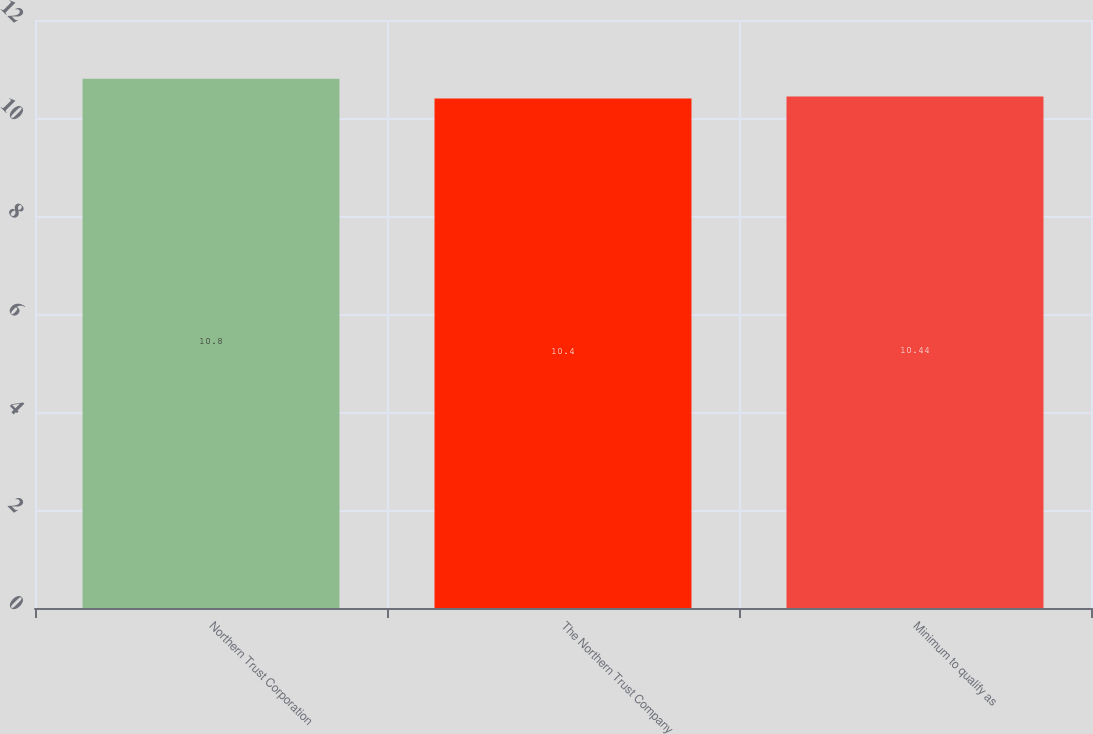<chart> <loc_0><loc_0><loc_500><loc_500><bar_chart><fcel>Northern Trust Corporation<fcel>The Northern Trust Company<fcel>Minimum to qualify as<nl><fcel>10.8<fcel>10.4<fcel>10.44<nl></chart> 